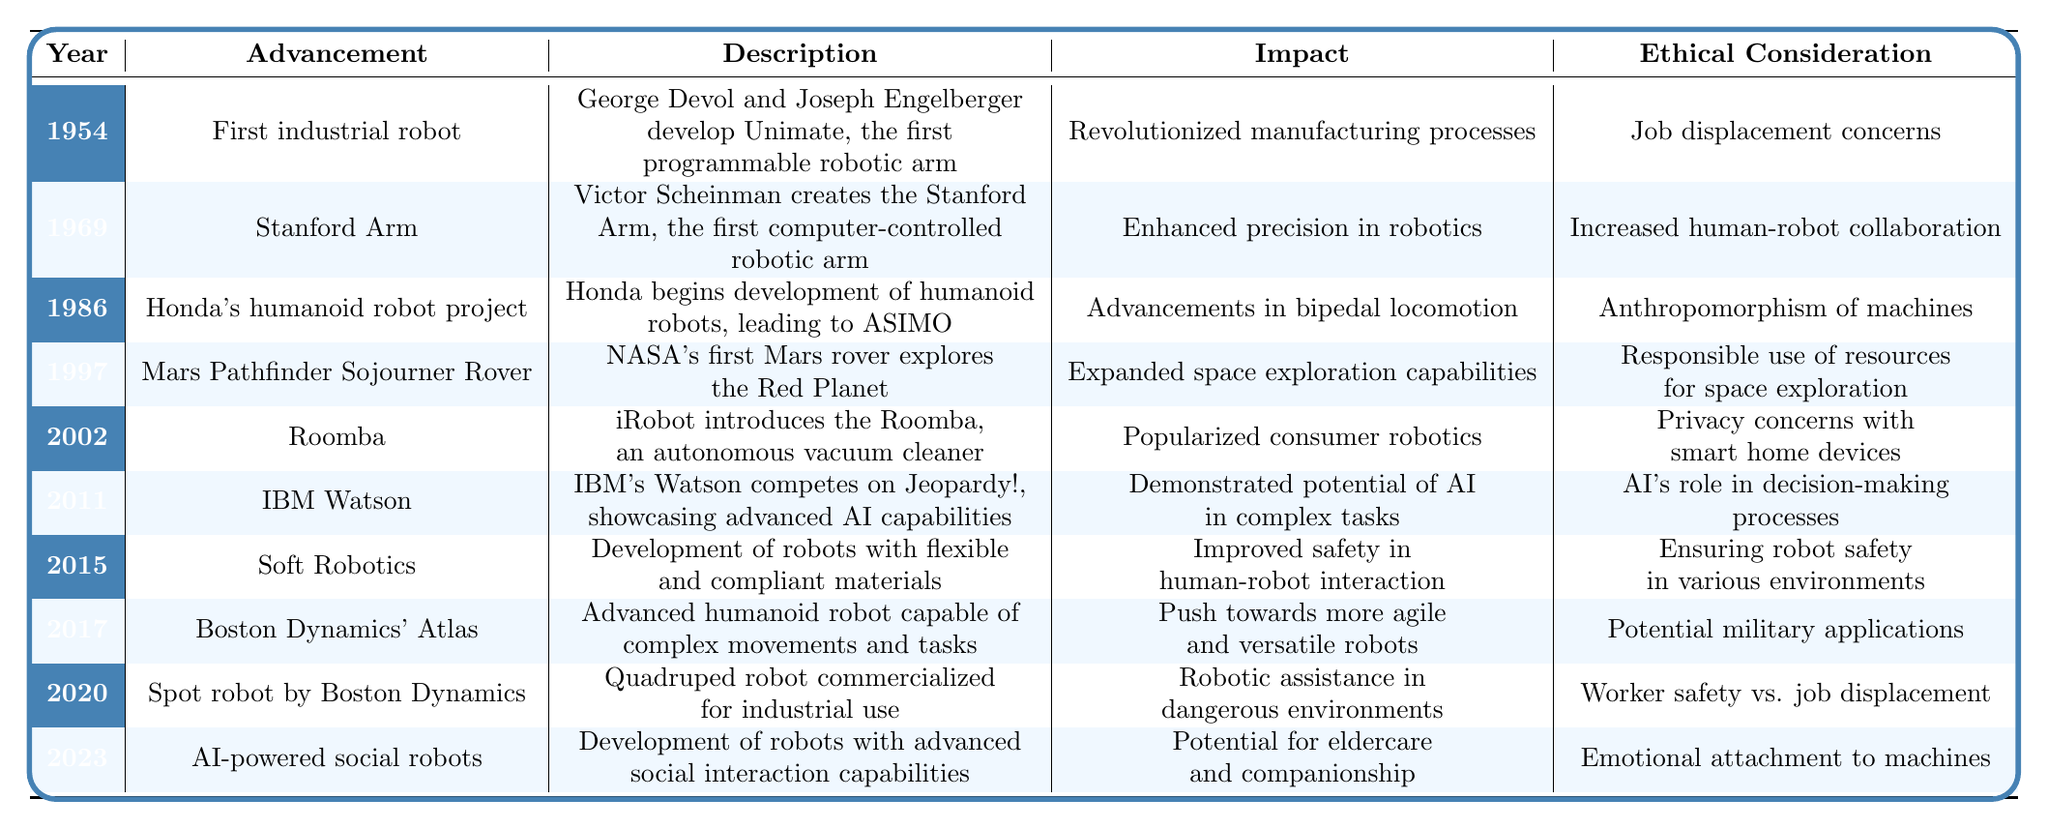What year was the first industrial robot introduced? The table indicates that the first industrial robot was introduced in 1954.
Answer: 1954 Who created the Stanford Arm? Victor Scheinman is the individual noted in the table as the creator of the Stanford Arm.
Answer: Victor Scheinman What advancement came after the development of Honda's humanoid robot project? According to the timeline, the advancement that followed Honda's humanoid robot project in 1986 is the Mars Pathfinder Sojourner Rover in 1997.
Answer: Mars Pathfinder Sojourner Rover What impact did the Roomba have? The table states that the Roomba popularized consumer robotics, which was its main impact.
Answer: Popularized consumer robotics Was the introduction of AI-powered social robots focused on eldercare? Yes, the table specifies that the development of AI-powered social robots in 2023 has the potential for eldercare and companionship.
Answer: Yes Which advancement had job displacement concerns listed under ethical considerations? The ethical considerations for the first industrial robot and the Spot robot both mention job displacement concerns.
Answer: First industrial robot and Spot robot How many advancements listed occurred between 2000 and 2010? In the table, two advancements fall between 2000 and 2010: Roomba in 2002 and IBM Watson in 2011, totaling to two advancements.
Answer: 2 What is the earliest year listed in the timeline? The earliest year in the timeline is 1954, where the first industrial robot was introduced.
Answer: 1954 Identify an advancement that improved safety in human-robot interaction. According to the table, the development of Soft Robotics in 2015 is noted for improving safety in human-robot interaction.
Answer: Soft Robotics How do the advancements from 2020 and 2023 relate in terms of ethical considerations? Both AI-powered social robots in 2023 and Spot robot in 2020 raise ethical considerations around job displacement and emotional attachment to machines, indicating a growing concern about humanity's connection to robots.
Answer: They both address ethical concerns regarding displacement and emotional attachment 